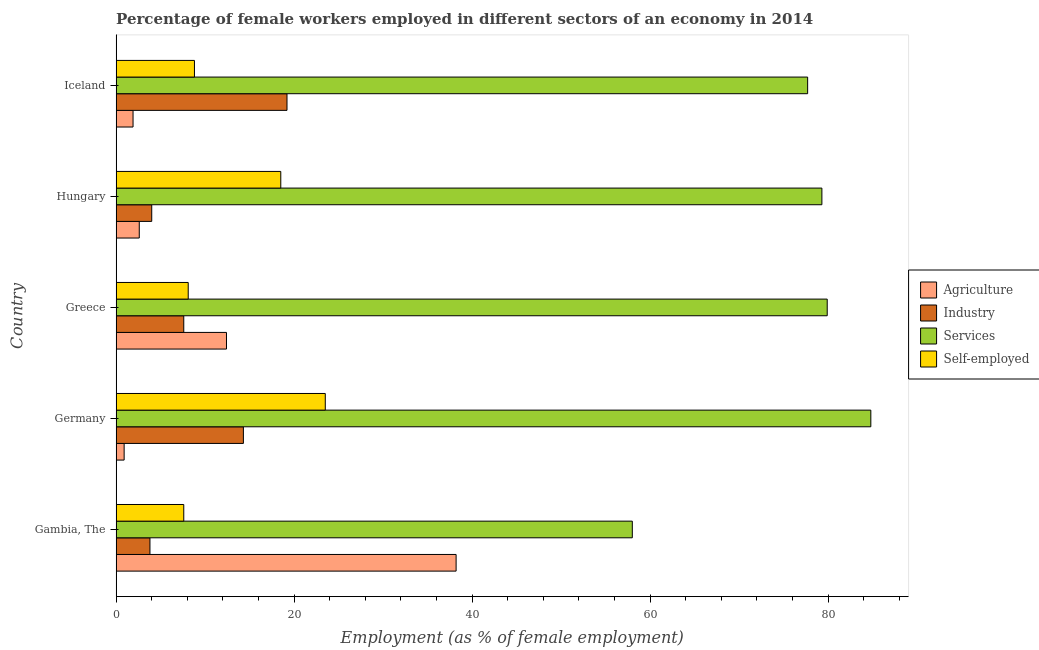How many different coloured bars are there?
Your answer should be very brief. 4. How many groups of bars are there?
Your response must be concise. 5. How many bars are there on the 1st tick from the top?
Offer a terse response. 4. How many bars are there on the 4th tick from the bottom?
Offer a very short reply. 4. In how many cases, is the number of bars for a given country not equal to the number of legend labels?
Make the answer very short. 0. What is the percentage of female workers in industry in Greece?
Your response must be concise. 7.6. Across all countries, what is the maximum percentage of female workers in services?
Your response must be concise. 84.8. In which country was the percentage of female workers in agriculture maximum?
Provide a succinct answer. Gambia, The. In which country was the percentage of female workers in services minimum?
Your response must be concise. Gambia, The. What is the total percentage of female workers in services in the graph?
Your answer should be compact. 379.7. What is the difference between the percentage of female workers in agriculture in Gambia, The and that in Iceland?
Provide a short and direct response. 36.3. What is the difference between the percentage of female workers in services in Hungary and the percentage of female workers in industry in Germany?
Keep it short and to the point. 65. What is the average percentage of female workers in services per country?
Give a very brief answer. 75.94. What is the difference between the percentage of female workers in services and percentage of female workers in industry in Greece?
Your answer should be very brief. 72.3. In how many countries, is the percentage of self employed female workers greater than 56 %?
Your answer should be very brief. 0. What is the ratio of the percentage of female workers in agriculture in Gambia, The to that in Greece?
Give a very brief answer. 3.08. Is the percentage of female workers in agriculture in Greece less than that in Hungary?
Make the answer very short. No. What is the difference between the highest and the second highest percentage of female workers in services?
Your response must be concise. 4.9. What is the difference between the highest and the lowest percentage of female workers in industry?
Give a very brief answer. 15.4. In how many countries, is the percentage of female workers in agriculture greater than the average percentage of female workers in agriculture taken over all countries?
Make the answer very short. 2. Is the sum of the percentage of female workers in industry in Gambia, The and Germany greater than the maximum percentage of female workers in services across all countries?
Keep it short and to the point. No. Is it the case that in every country, the sum of the percentage of self employed female workers and percentage of female workers in services is greater than the sum of percentage of female workers in agriculture and percentage of female workers in industry?
Offer a terse response. Yes. What does the 3rd bar from the top in Iceland represents?
Your answer should be compact. Industry. What does the 4th bar from the bottom in Greece represents?
Ensure brevity in your answer.  Self-employed. How many bars are there?
Your answer should be very brief. 20. What is the difference between two consecutive major ticks on the X-axis?
Offer a terse response. 20. Where does the legend appear in the graph?
Make the answer very short. Center right. How many legend labels are there?
Provide a short and direct response. 4. How are the legend labels stacked?
Give a very brief answer. Vertical. What is the title of the graph?
Give a very brief answer. Percentage of female workers employed in different sectors of an economy in 2014. What is the label or title of the X-axis?
Keep it short and to the point. Employment (as % of female employment). What is the label or title of the Y-axis?
Keep it short and to the point. Country. What is the Employment (as % of female employment) of Agriculture in Gambia, The?
Offer a terse response. 38.2. What is the Employment (as % of female employment) in Industry in Gambia, The?
Offer a very short reply. 3.8. What is the Employment (as % of female employment) in Services in Gambia, The?
Your answer should be compact. 58. What is the Employment (as % of female employment) in Self-employed in Gambia, The?
Provide a succinct answer. 7.6. What is the Employment (as % of female employment) in Agriculture in Germany?
Offer a very short reply. 0.9. What is the Employment (as % of female employment) in Industry in Germany?
Offer a terse response. 14.3. What is the Employment (as % of female employment) in Services in Germany?
Make the answer very short. 84.8. What is the Employment (as % of female employment) of Agriculture in Greece?
Make the answer very short. 12.4. What is the Employment (as % of female employment) in Industry in Greece?
Your answer should be very brief. 7.6. What is the Employment (as % of female employment) in Services in Greece?
Give a very brief answer. 79.9. What is the Employment (as % of female employment) of Self-employed in Greece?
Make the answer very short. 8.1. What is the Employment (as % of female employment) in Agriculture in Hungary?
Offer a very short reply. 2.6. What is the Employment (as % of female employment) of Industry in Hungary?
Give a very brief answer. 4. What is the Employment (as % of female employment) of Services in Hungary?
Your answer should be compact. 79.3. What is the Employment (as % of female employment) in Self-employed in Hungary?
Keep it short and to the point. 18.5. What is the Employment (as % of female employment) of Agriculture in Iceland?
Your answer should be compact. 1.9. What is the Employment (as % of female employment) of Industry in Iceland?
Keep it short and to the point. 19.2. What is the Employment (as % of female employment) in Services in Iceland?
Provide a short and direct response. 77.7. What is the Employment (as % of female employment) in Self-employed in Iceland?
Offer a very short reply. 8.8. Across all countries, what is the maximum Employment (as % of female employment) of Agriculture?
Give a very brief answer. 38.2. Across all countries, what is the maximum Employment (as % of female employment) in Industry?
Provide a short and direct response. 19.2. Across all countries, what is the maximum Employment (as % of female employment) in Services?
Make the answer very short. 84.8. Across all countries, what is the maximum Employment (as % of female employment) in Self-employed?
Make the answer very short. 23.5. Across all countries, what is the minimum Employment (as % of female employment) of Agriculture?
Your answer should be very brief. 0.9. Across all countries, what is the minimum Employment (as % of female employment) in Industry?
Ensure brevity in your answer.  3.8. Across all countries, what is the minimum Employment (as % of female employment) of Services?
Provide a succinct answer. 58. Across all countries, what is the minimum Employment (as % of female employment) in Self-employed?
Provide a short and direct response. 7.6. What is the total Employment (as % of female employment) of Industry in the graph?
Provide a succinct answer. 48.9. What is the total Employment (as % of female employment) in Services in the graph?
Keep it short and to the point. 379.7. What is the total Employment (as % of female employment) of Self-employed in the graph?
Give a very brief answer. 66.5. What is the difference between the Employment (as % of female employment) in Agriculture in Gambia, The and that in Germany?
Your answer should be compact. 37.3. What is the difference between the Employment (as % of female employment) of Industry in Gambia, The and that in Germany?
Ensure brevity in your answer.  -10.5. What is the difference between the Employment (as % of female employment) in Services in Gambia, The and that in Germany?
Your response must be concise. -26.8. What is the difference between the Employment (as % of female employment) of Self-employed in Gambia, The and that in Germany?
Provide a short and direct response. -15.9. What is the difference between the Employment (as % of female employment) of Agriculture in Gambia, The and that in Greece?
Your response must be concise. 25.8. What is the difference between the Employment (as % of female employment) in Industry in Gambia, The and that in Greece?
Your answer should be compact. -3.8. What is the difference between the Employment (as % of female employment) of Services in Gambia, The and that in Greece?
Ensure brevity in your answer.  -21.9. What is the difference between the Employment (as % of female employment) in Agriculture in Gambia, The and that in Hungary?
Provide a short and direct response. 35.6. What is the difference between the Employment (as % of female employment) of Industry in Gambia, The and that in Hungary?
Provide a succinct answer. -0.2. What is the difference between the Employment (as % of female employment) in Services in Gambia, The and that in Hungary?
Your answer should be compact. -21.3. What is the difference between the Employment (as % of female employment) in Self-employed in Gambia, The and that in Hungary?
Keep it short and to the point. -10.9. What is the difference between the Employment (as % of female employment) of Agriculture in Gambia, The and that in Iceland?
Provide a short and direct response. 36.3. What is the difference between the Employment (as % of female employment) of Industry in Gambia, The and that in Iceland?
Offer a terse response. -15.4. What is the difference between the Employment (as % of female employment) in Services in Gambia, The and that in Iceland?
Offer a very short reply. -19.7. What is the difference between the Employment (as % of female employment) in Self-employed in Gambia, The and that in Iceland?
Keep it short and to the point. -1.2. What is the difference between the Employment (as % of female employment) of Agriculture in Germany and that in Greece?
Your answer should be compact. -11.5. What is the difference between the Employment (as % of female employment) of Industry in Germany and that in Greece?
Ensure brevity in your answer.  6.7. What is the difference between the Employment (as % of female employment) of Self-employed in Germany and that in Greece?
Give a very brief answer. 15.4. What is the difference between the Employment (as % of female employment) in Agriculture in Germany and that in Hungary?
Offer a very short reply. -1.7. What is the difference between the Employment (as % of female employment) in Self-employed in Germany and that in Hungary?
Ensure brevity in your answer.  5. What is the difference between the Employment (as % of female employment) of Agriculture in Germany and that in Iceland?
Give a very brief answer. -1. What is the difference between the Employment (as % of female employment) of Self-employed in Germany and that in Iceland?
Make the answer very short. 14.7. What is the difference between the Employment (as % of female employment) of Agriculture in Greece and that in Hungary?
Make the answer very short. 9.8. What is the difference between the Employment (as % of female employment) in Industry in Greece and that in Hungary?
Provide a short and direct response. 3.6. What is the difference between the Employment (as % of female employment) of Services in Greece and that in Hungary?
Make the answer very short. 0.6. What is the difference between the Employment (as % of female employment) of Agriculture in Greece and that in Iceland?
Provide a succinct answer. 10.5. What is the difference between the Employment (as % of female employment) in Industry in Hungary and that in Iceland?
Give a very brief answer. -15.2. What is the difference between the Employment (as % of female employment) in Self-employed in Hungary and that in Iceland?
Provide a succinct answer. 9.7. What is the difference between the Employment (as % of female employment) in Agriculture in Gambia, The and the Employment (as % of female employment) in Industry in Germany?
Keep it short and to the point. 23.9. What is the difference between the Employment (as % of female employment) in Agriculture in Gambia, The and the Employment (as % of female employment) in Services in Germany?
Ensure brevity in your answer.  -46.6. What is the difference between the Employment (as % of female employment) of Agriculture in Gambia, The and the Employment (as % of female employment) of Self-employed in Germany?
Offer a very short reply. 14.7. What is the difference between the Employment (as % of female employment) in Industry in Gambia, The and the Employment (as % of female employment) in Services in Germany?
Provide a short and direct response. -81. What is the difference between the Employment (as % of female employment) in Industry in Gambia, The and the Employment (as % of female employment) in Self-employed in Germany?
Provide a succinct answer. -19.7. What is the difference between the Employment (as % of female employment) of Services in Gambia, The and the Employment (as % of female employment) of Self-employed in Germany?
Provide a succinct answer. 34.5. What is the difference between the Employment (as % of female employment) of Agriculture in Gambia, The and the Employment (as % of female employment) of Industry in Greece?
Make the answer very short. 30.6. What is the difference between the Employment (as % of female employment) of Agriculture in Gambia, The and the Employment (as % of female employment) of Services in Greece?
Ensure brevity in your answer.  -41.7. What is the difference between the Employment (as % of female employment) in Agriculture in Gambia, The and the Employment (as % of female employment) in Self-employed in Greece?
Offer a terse response. 30.1. What is the difference between the Employment (as % of female employment) of Industry in Gambia, The and the Employment (as % of female employment) of Services in Greece?
Ensure brevity in your answer.  -76.1. What is the difference between the Employment (as % of female employment) in Industry in Gambia, The and the Employment (as % of female employment) in Self-employed in Greece?
Your answer should be compact. -4.3. What is the difference between the Employment (as % of female employment) of Services in Gambia, The and the Employment (as % of female employment) of Self-employed in Greece?
Give a very brief answer. 49.9. What is the difference between the Employment (as % of female employment) in Agriculture in Gambia, The and the Employment (as % of female employment) in Industry in Hungary?
Keep it short and to the point. 34.2. What is the difference between the Employment (as % of female employment) of Agriculture in Gambia, The and the Employment (as % of female employment) of Services in Hungary?
Your answer should be very brief. -41.1. What is the difference between the Employment (as % of female employment) of Agriculture in Gambia, The and the Employment (as % of female employment) of Self-employed in Hungary?
Provide a short and direct response. 19.7. What is the difference between the Employment (as % of female employment) in Industry in Gambia, The and the Employment (as % of female employment) in Services in Hungary?
Offer a very short reply. -75.5. What is the difference between the Employment (as % of female employment) of Industry in Gambia, The and the Employment (as % of female employment) of Self-employed in Hungary?
Make the answer very short. -14.7. What is the difference between the Employment (as % of female employment) of Services in Gambia, The and the Employment (as % of female employment) of Self-employed in Hungary?
Provide a short and direct response. 39.5. What is the difference between the Employment (as % of female employment) in Agriculture in Gambia, The and the Employment (as % of female employment) in Industry in Iceland?
Make the answer very short. 19. What is the difference between the Employment (as % of female employment) of Agriculture in Gambia, The and the Employment (as % of female employment) of Services in Iceland?
Provide a short and direct response. -39.5. What is the difference between the Employment (as % of female employment) in Agriculture in Gambia, The and the Employment (as % of female employment) in Self-employed in Iceland?
Offer a very short reply. 29.4. What is the difference between the Employment (as % of female employment) of Industry in Gambia, The and the Employment (as % of female employment) of Services in Iceland?
Provide a short and direct response. -73.9. What is the difference between the Employment (as % of female employment) in Services in Gambia, The and the Employment (as % of female employment) in Self-employed in Iceland?
Provide a short and direct response. 49.2. What is the difference between the Employment (as % of female employment) in Agriculture in Germany and the Employment (as % of female employment) in Services in Greece?
Offer a very short reply. -79. What is the difference between the Employment (as % of female employment) in Agriculture in Germany and the Employment (as % of female employment) in Self-employed in Greece?
Your answer should be very brief. -7.2. What is the difference between the Employment (as % of female employment) in Industry in Germany and the Employment (as % of female employment) in Services in Greece?
Keep it short and to the point. -65.6. What is the difference between the Employment (as % of female employment) of Industry in Germany and the Employment (as % of female employment) of Self-employed in Greece?
Provide a short and direct response. 6.2. What is the difference between the Employment (as % of female employment) in Services in Germany and the Employment (as % of female employment) in Self-employed in Greece?
Ensure brevity in your answer.  76.7. What is the difference between the Employment (as % of female employment) of Agriculture in Germany and the Employment (as % of female employment) of Industry in Hungary?
Keep it short and to the point. -3.1. What is the difference between the Employment (as % of female employment) of Agriculture in Germany and the Employment (as % of female employment) of Services in Hungary?
Offer a terse response. -78.4. What is the difference between the Employment (as % of female employment) of Agriculture in Germany and the Employment (as % of female employment) of Self-employed in Hungary?
Provide a short and direct response. -17.6. What is the difference between the Employment (as % of female employment) of Industry in Germany and the Employment (as % of female employment) of Services in Hungary?
Keep it short and to the point. -65. What is the difference between the Employment (as % of female employment) in Services in Germany and the Employment (as % of female employment) in Self-employed in Hungary?
Keep it short and to the point. 66.3. What is the difference between the Employment (as % of female employment) in Agriculture in Germany and the Employment (as % of female employment) in Industry in Iceland?
Provide a succinct answer. -18.3. What is the difference between the Employment (as % of female employment) of Agriculture in Germany and the Employment (as % of female employment) of Services in Iceland?
Your answer should be compact. -76.8. What is the difference between the Employment (as % of female employment) in Industry in Germany and the Employment (as % of female employment) in Services in Iceland?
Keep it short and to the point. -63.4. What is the difference between the Employment (as % of female employment) in Services in Germany and the Employment (as % of female employment) in Self-employed in Iceland?
Offer a terse response. 76. What is the difference between the Employment (as % of female employment) in Agriculture in Greece and the Employment (as % of female employment) in Services in Hungary?
Keep it short and to the point. -66.9. What is the difference between the Employment (as % of female employment) of Agriculture in Greece and the Employment (as % of female employment) of Self-employed in Hungary?
Keep it short and to the point. -6.1. What is the difference between the Employment (as % of female employment) of Industry in Greece and the Employment (as % of female employment) of Services in Hungary?
Give a very brief answer. -71.7. What is the difference between the Employment (as % of female employment) in Services in Greece and the Employment (as % of female employment) in Self-employed in Hungary?
Offer a terse response. 61.4. What is the difference between the Employment (as % of female employment) of Agriculture in Greece and the Employment (as % of female employment) of Industry in Iceland?
Your answer should be compact. -6.8. What is the difference between the Employment (as % of female employment) of Agriculture in Greece and the Employment (as % of female employment) of Services in Iceland?
Provide a short and direct response. -65.3. What is the difference between the Employment (as % of female employment) in Agriculture in Greece and the Employment (as % of female employment) in Self-employed in Iceland?
Offer a terse response. 3.6. What is the difference between the Employment (as % of female employment) of Industry in Greece and the Employment (as % of female employment) of Services in Iceland?
Provide a short and direct response. -70.1. What is the difference between the Employment (as % of female employment) in Services in Greece and the Employment (as % of female employment) in Self-employed in Iceland?
Make the answer very short. 71.1. What is the difference between the Employment (as % of female employment) of Agriculture in Hungary and the Employment (as % of female employment) of Industry in Iceland?
Offer a terse response. -16.6. What is the difference between the Employment (as % of female employment) in Agriculture in Hungary and the Employment (as % of female employment) in Services in Iceland?
Ensure brevity in your answer.  -75.1. What is the difference between the Employment (as % of female employment) of Industry in Hungary and the Employment (as % of female employment) of Services in Iceland?
Offer a very short reply. -73.7. What is the difference between the Employment (as % of female employment) in Industry in Hungary and the Employment (as % of female employment) in Self-employed in Iceland?
Provide a succinct answer. -4.8. What is the difference between the Employment (as % of female employment) in Services in Hungary and the Employment (as % of female employment) in Self-employed in Iceland?
Provide a short and direct response. 70.5. What is the average Employment (as % of female employment) of Industry per country?
Offer a very short reply. 9.78. What is the average Employment (as % of female employment) of Services per country?
Keep it short and to the point. 75.94. What is the average Employment (as % of female employment) of Self-employed per country?
Your response must be concise. 13.3. What is the difference between the Employment (as % of female employment) in Agriculture and Employment (as % of female employment) in Industry in Gambia, The?
Provide a succinct answer. 34.4. What is the difference between the Employment (as % of female employment) in Agriculture and Employment (as % of female employment) in Services in Gambia, The?
Keep it short and to the point. -19.8. What is the difference between the Employment (as % of female employment) in Agriculture and Employment (as % of female employment) in Self-employed in Gambia, The?
Your answer should be very brief. 30.6. What is the difference between the Employment (as % of female employment) in Industry and Employment (as % of female employment) in Services in Gambia, The?
Ensure brevity in your answer.  -54.2. What is the difference between the Employment (as % of female employment) in Industry and Employment (as % of female employment) in Self-employed in Gambia, The?
Your answer should be compact. -3.8. What is the difference between the Employment (as % of female employment) in Services and Employment (as % of female employment) in Self-employed in Gambia, The?
Provide a short and direct response. 50.4. What is the difference between the Employment (as % of female employment) of Agriculture and Employment (as % of female employment) of Services in Germany?
Offer a terse response. -83.9. What is the difference between the Employment (as % of female employment) of Agriculture and Employment (as % of female employment) of Self-employed in Germany?
Provide a succinct answer. -22.6. What is the difference between the Employment (as % of female employment) of Industry and Employment (as % of female employment) of Services in Germany?
Offer a terse response. -70.5. What is the difference between the Employment (as % of female employment) of Industry and Employment (as % of female employment) of Self-employed in Germany?
Provide a succinct answer. -9.2. What is the difference between the Employment (as % of female employment) of Services and Employment (as % of female employment) of Self-employed in Germany?
Your answer should be very brief. 61.3. What is the difference between the Employment (as % of female employment) of Agriculture and Employment (as % of female employment) of Industry in Greece?
Keep it short and to the point. 4.8. What is the difference between the Employment (as % of female employment) in Agriculture and Employment (as % of female employment) in Services in Greece?
Your answer should be very brief. -67.5. What is the difference between the Employment (as % of female employment) of Industry and Employment (as % of female employment) of Services in Greece?
Your response must be concise. -72.3. What is the difference between the Employment (as % of female employment) of Services and Employment (as % of female employment) of Self-employed in Greece?
Your answer should be compact. 71.8. What is the difference between the Employment (as % of female employment) in Agriculture and Employment (as % of female employment) in Services in Hungary?
Your response must be concise. -76.7. What is the difference between the Employment (as % of female employment) of Agriculture and Employment (as % of female employment) of Self-employed in Hungary?
Offer a very short reply. -15.9. What is the difference between the Employment (as % of female employment) of Industry and Employment (as % of female employment) of Services in Hungary?
Offer a terse response. -75.3. What is the difference between the Employment (as % of female employment) of Services and Employment (as % of female employment) of Self-employed in Hungary?
Give a very brief answer. 60.8. What is the difference between the Employment (as % of female employment) of Agriculture and Employment (as % of female employment) of Industry in Iceland?
Provide a succinct answer. -17.3. What is the difference between the Employment (as % of female employment) in Agriculture and Employment (as % of female employment) in Services in Iceland?
Provide a succinct answer. -75.8. What is the difference between the Employment (as % of female employment) in Agriculture and Employment (as % of female employment) in Self-employed in Iceland?
Keep it short and to the point. -6.9. What is the difference between the Employment (as % of female employment) in Industry and Employment (as % of female employment) in Services in Iceland?
Offer a very short reply. -58.5. What is the difference between the Employment (as % of female employment) in Services and Employment (as % of female employment) in Self-employed in Iceland?
Ensure brevity in your answer.  68.9. What is the ratio of the Employment (as % of female employment) in Agriculture in Gambia, The to that in Germany?
Your answer should be compact. 42.44. What is the ratio of the Employment (as % of female employment) of Industry in Gambia, The to that in Germany?
Offer a terse response. 0.27. What is the ratio of the Employment (as % of female employment) of Services in Gambia, The to that in Germany?
Provide a short and direct response. 0.68. What is the ratio of the Employment (as % of female employment) in Self-employed in Gambia, The to that in Germany?
Give a very brief answer. 0.32. What is the ratio of the Employment (as % of female employment) in Agriculture in Gambia, The to that in Greece?
Make the answer very short. 3.08. What is the ratio of the Employment (as % of female employment) in Services in Gambia, The to that in Greece?
Your answer should be very brief. 0.73. What is the ratio of the Employment (as % of female employment) in Self-employed in Gambia, The to that in Greece?
Make the answer very short. 0.94. What is the ratio of the Employment (as % of female employment) of Agriculture in Gambia, The to that in Hungary?
Provide a succinct answer. 14.69. What is the ratio of the Employment (as % of female employment) in Industry in Gambia, The to that in Hungary?
Provide a short and direct response. 0.95. What is the ratio of the Employment (as % of female employment) of Services in Gambia, The to that in Hungary?
Give a very brief answer. 0.73. What is the ratio of the Employment (as % of female employment) of Self-employed in Gambia, The to that in Hungary?
Give a very brief answer. 0.41. What is the ratio of the Employment (as % of female employment) in Agriculture in Gambia, The to that in Iceland?
Make the answer very short. 20.11. What is the ratio of the Employment (as % of female employment) of Industry in Gambia, The to that in Iceland?
Offer a very short reply. 0.2. What is the ratio of the Employment (as % of female employment) of Services in Gambia, The to that in Iceland?
Offer a very short reply. 0.75. What is the ratio of the Employment (as % of female employment) in Self-employed in Gambia, The to that in Iceland?
Offer a terse response. 0.86. What is the ratio of the Employment (as % of female employment) of Agriculture in Germany to that in Greece?
Provide a short and direct response. 0.07. What is the ratio of the Employment (as % of female employment) of Industry in Germany to that in Greece?
Make the answer very short. 1.88. What is the ratio of the Employment (as % of female employment) of Services in Germany to that in Greece?
Keep it short and to the point. 1.06. What is the ratio of the Employment (as % of female employment) of Self-employed in Germany to that in Greece?
Keep it short and to the point. 2.9. What is the ratio of the Employment (as % of female employment) of Agriculture in Germany to that in Hungary?
Your answer should be very brief. 0.35. What is the ratio of the Employment (as % of female employment) in Industry in Germany to that in Hungary?
Your answer should be compact. 3.58. What is the ratio of the Employment (as % of female employment) in Services in Germany to that in Hungary?
Your answer should be compact. 1.07. What is the ratio of the Employment (as % of female employment) of Self-employed in Germany to that in Hungary?
Make the answer very short. 1.27. What is the ratio of the Employment (as % of female employment) in Agriculture in Germany to that in Iceland?
Provide a succinct answer. 0.47. What is the ratio of the Employment (as % of female employment) in Industry in Germany to that in Iceland?
Your answer should be compact. 0.74. What is the ratio of the Employment (as % of female employment) in Services in Germany to that in Iceland?
Offer a very short reply. 1.09. What is the ratio of the Employment (as % of female employment) of Self-employed in Germany to that in Iceland?
Your answer should be very brief. 2.67. What is the ratio of the Employment (as % of female employment) of Agriculture in Greece to that in Hungary?
Offer a terse response. 4.77. What is the ratio of the Employment (as % of female employment) in Industry in Greece to that in Hungary?
Your answer should be compact. 1.9. What is the ratio of the Employment (as % of female employment) in Services in Greece to that in Hungary?
Offer a terse response. 1.01. What is the ratio of the Employment (as % of female employment) in Self-employed in Greece to that in Hungary?
Provide a succinct answer. 0.44. What is the ratio of the Employment (as % of female employment) of Agriculture in Greece to that in Iceland?
Your answer should be compact. 6.53. What is the ratio of the Employment (as % of female employment) of Industry in Greece to that in Iceland?
Offer a very short reply. 0.4. What is the ratio of the Employment (as % of female employment) in Services in Greece to that in Iceland?
Offer a very short reply. 1.03. What is the ratio of the Employment (as % of female employment) in Self-employed in Greece to that in Iceland?
Ensure brevity in your answer.  0.92. What is the ratio of the Employment (as % of female employment) in Agriculture in Hungary to that in Iceland?
Offer a very short reply. 1.37. What is the ratio of the Employment (as % of female employment) of Industry in Hungary to that in Iceland?
Give a very brief answer. 0.21. What is the ratio of the Employment (as % of female employment) in Services in Hungary to that in Iceland?
Give a very brief answer. 1.02. What is the ratio of the Employment (as % of female employment) in Self-employed in Hungary to that in Iceland?
Your answer should be compact. 2.1. What is the difference between the highest and the second highest Employment (as % of female employment) in Agriculture?
Provide a short and direct response. 25.8. What is the difference between the highest and the second highest Employment (as % of female employment) in Industry?
Provide a succinct answer. 4.9. What is the difference between the highest and the second highest Employment (as % of female employment) in Services?
Make the answer very short. 4.9. What is the difference between the highest and the second highest Employment (as % of female employment) of Self-employed?
Your answer should be compact. 5. What is the difference between the highest and the lowest Employment (as % of female employment) in Agriculture?
Provide a short and direct response. 37.3. What is the difference between the highest and the lowest Employment (as % of female employment) of Industry?
Your answer should be compact. 15.4. What is the difference between the highest and the lowest Employment (as % of female employment) of Services?
Your answer should be very brief. 26.8. What is the difference between the highest and the lowest Employment (as % of female employment) in Self-employed?
Give a very brief answer. 15.9. 